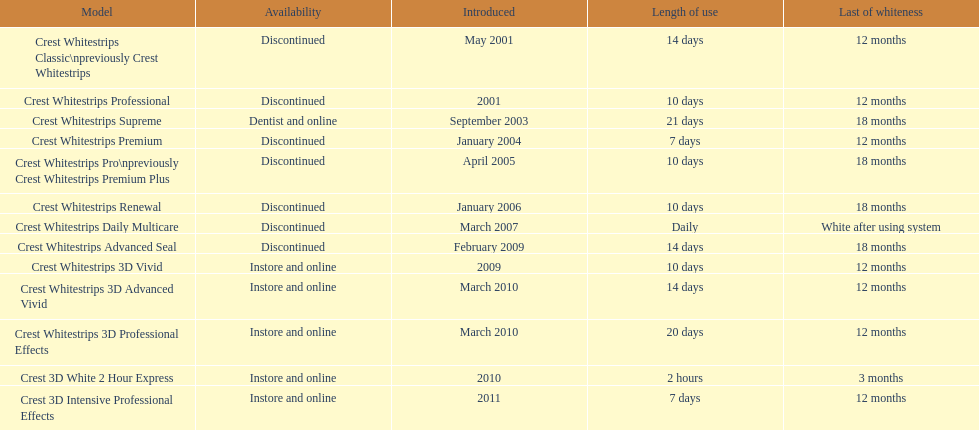What product was introduced in the same month as crest whitestrips 3d advanced vivid? Crest Whitestrips 3D Professional Effects. 